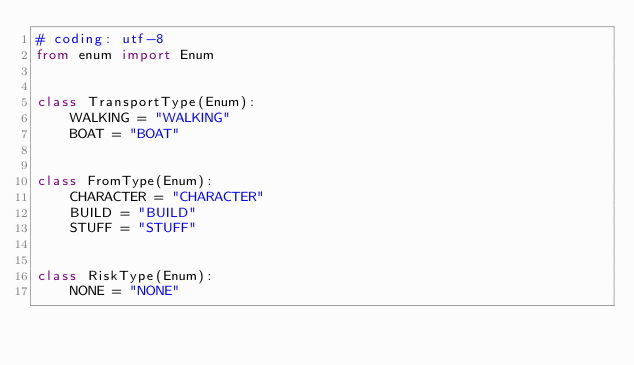<code> <loc_0><loc_0><loc_500><loc_500><_Python_># coding: utf-8
from enum import Enum


class TransportType(Enum):
    WALKING = "WALKING"
    BOAT = "BOAT"


class FromType(Enum):
    CHARACTER = "CHARACTER"
    BUILD = "BUILD"
    STUFF = "STUFF"


class RiskType(Enum):
    NONE = "NONE"
</code> 